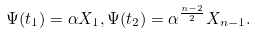<formula> <loc_0><loc_0><loc_500><loc_500>\Psi ( t _ { 1 } ) = \alpha X _ { 1 } , \Psi ( t _ { 2 } ) = \alpha ^ { \frac { n - 2 } { 2 } } X _ { n - 1 } .</formula> 